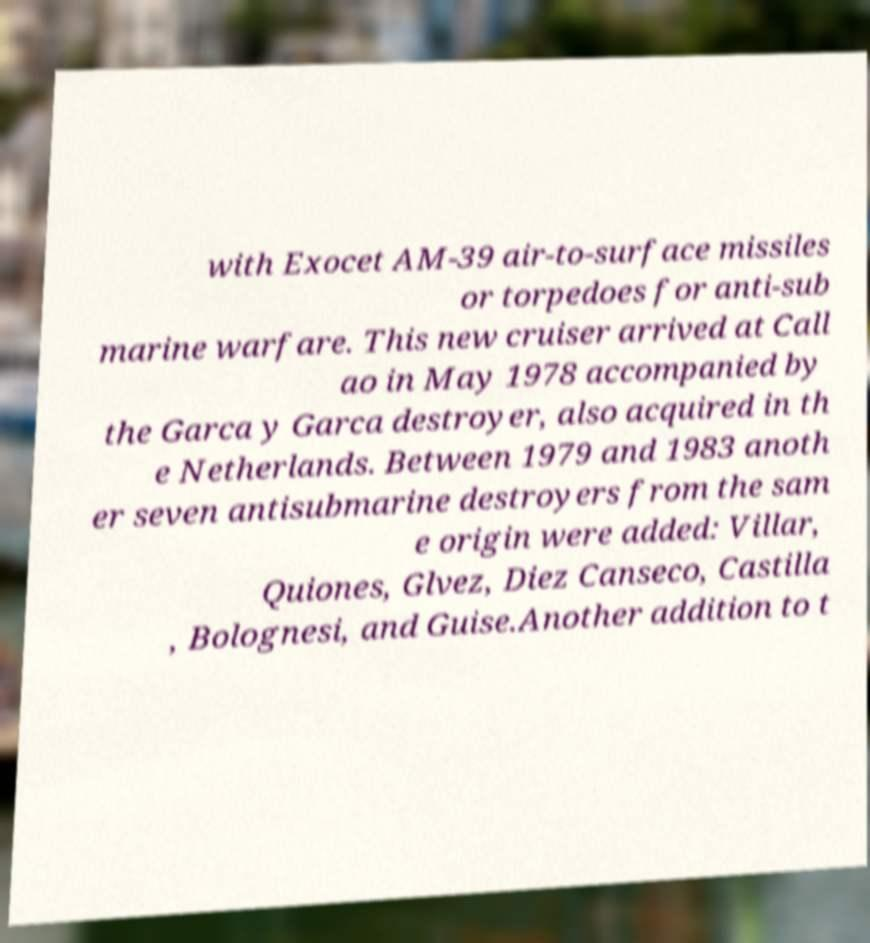Can you accurately transcribe the text from the provided image for me? with Exocet AM-39 air-to-surface missiles or torpedoes for anti-sub marine warfare. This new cruiser arrived at Call ao in May 1978 accompanied by the Garca y Garca destroyer, also acquired in th e Netherlands. Between 1979 and 1983 anoth er seven antisubmarine destroyers from the sam e origin were added: Villar, Quiones, Glvez, Diez Canseco, Castilla , Bolognesi, and Guise.Another addition to t 